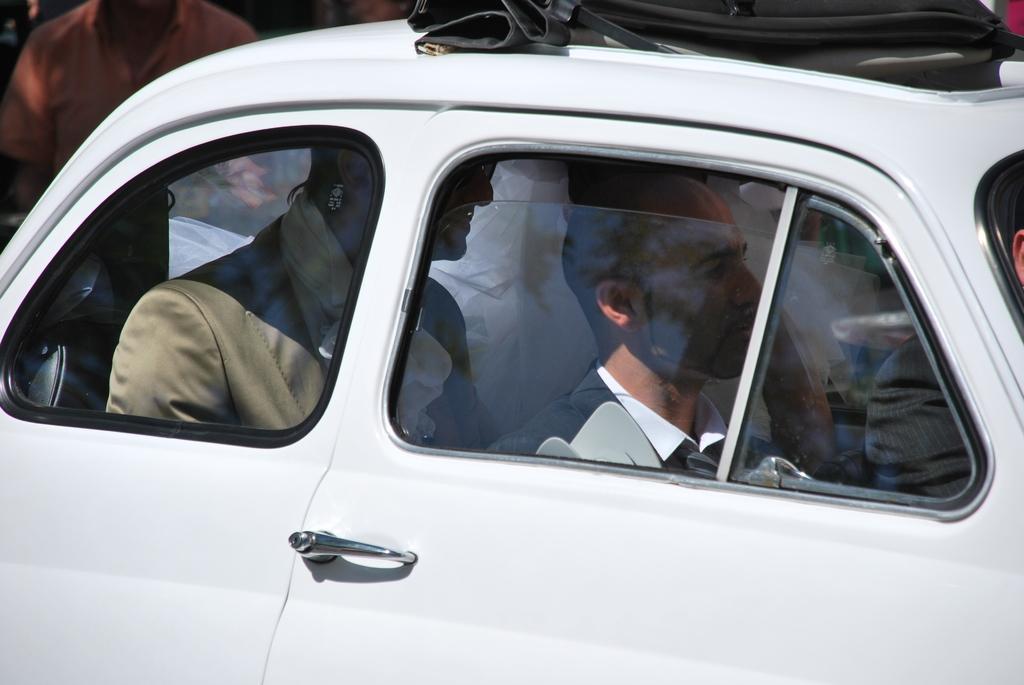Could you give a brief overview of what you see in this image? In this picture we see a car and people travelling in it. 